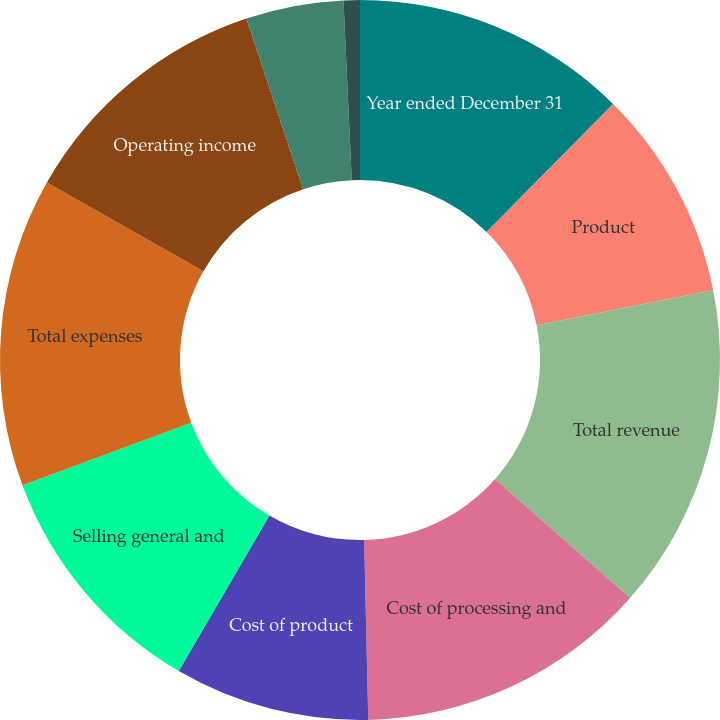Convert chart. <chart><loc_0><loc_0><loc_500><loc_500><pie_chart><fcel>Year ended December 31<fcel>Product<fcel>Total revenue<fcel>Cost of processing and<fcel>Cost of product<fcel>Selling general and<fcel>Total expenses<fcel>Operating income<fcel>Interest expense<fcel>Interest and investment income<nl><fcel>12.41%<fcel>9.49%<fcel>14.6%<fcel>13.14%<fcel>8.76%<fcel>10.95%<fcel>13.87%<fcel>11.68%<fcel>4.38%<fcel>0.73%<nl></chart> 